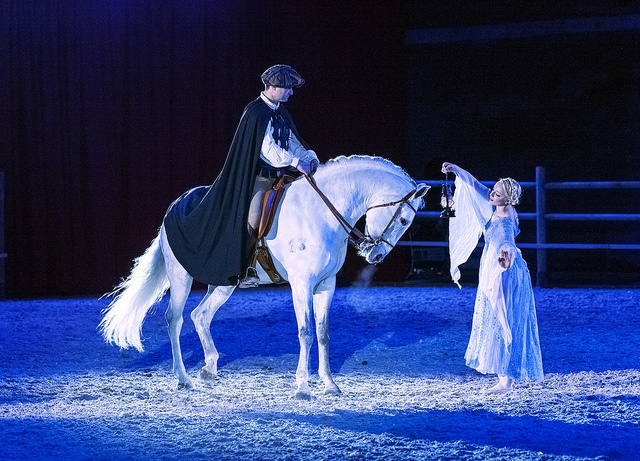Describe the objects in this image and their specific colors. I can see horse in navy, lavender, lightblue, gray, and black tones, people in navy, black, lavender, and blue tones, and people in navy, lavender, lightblue, and blue tones in this image. 